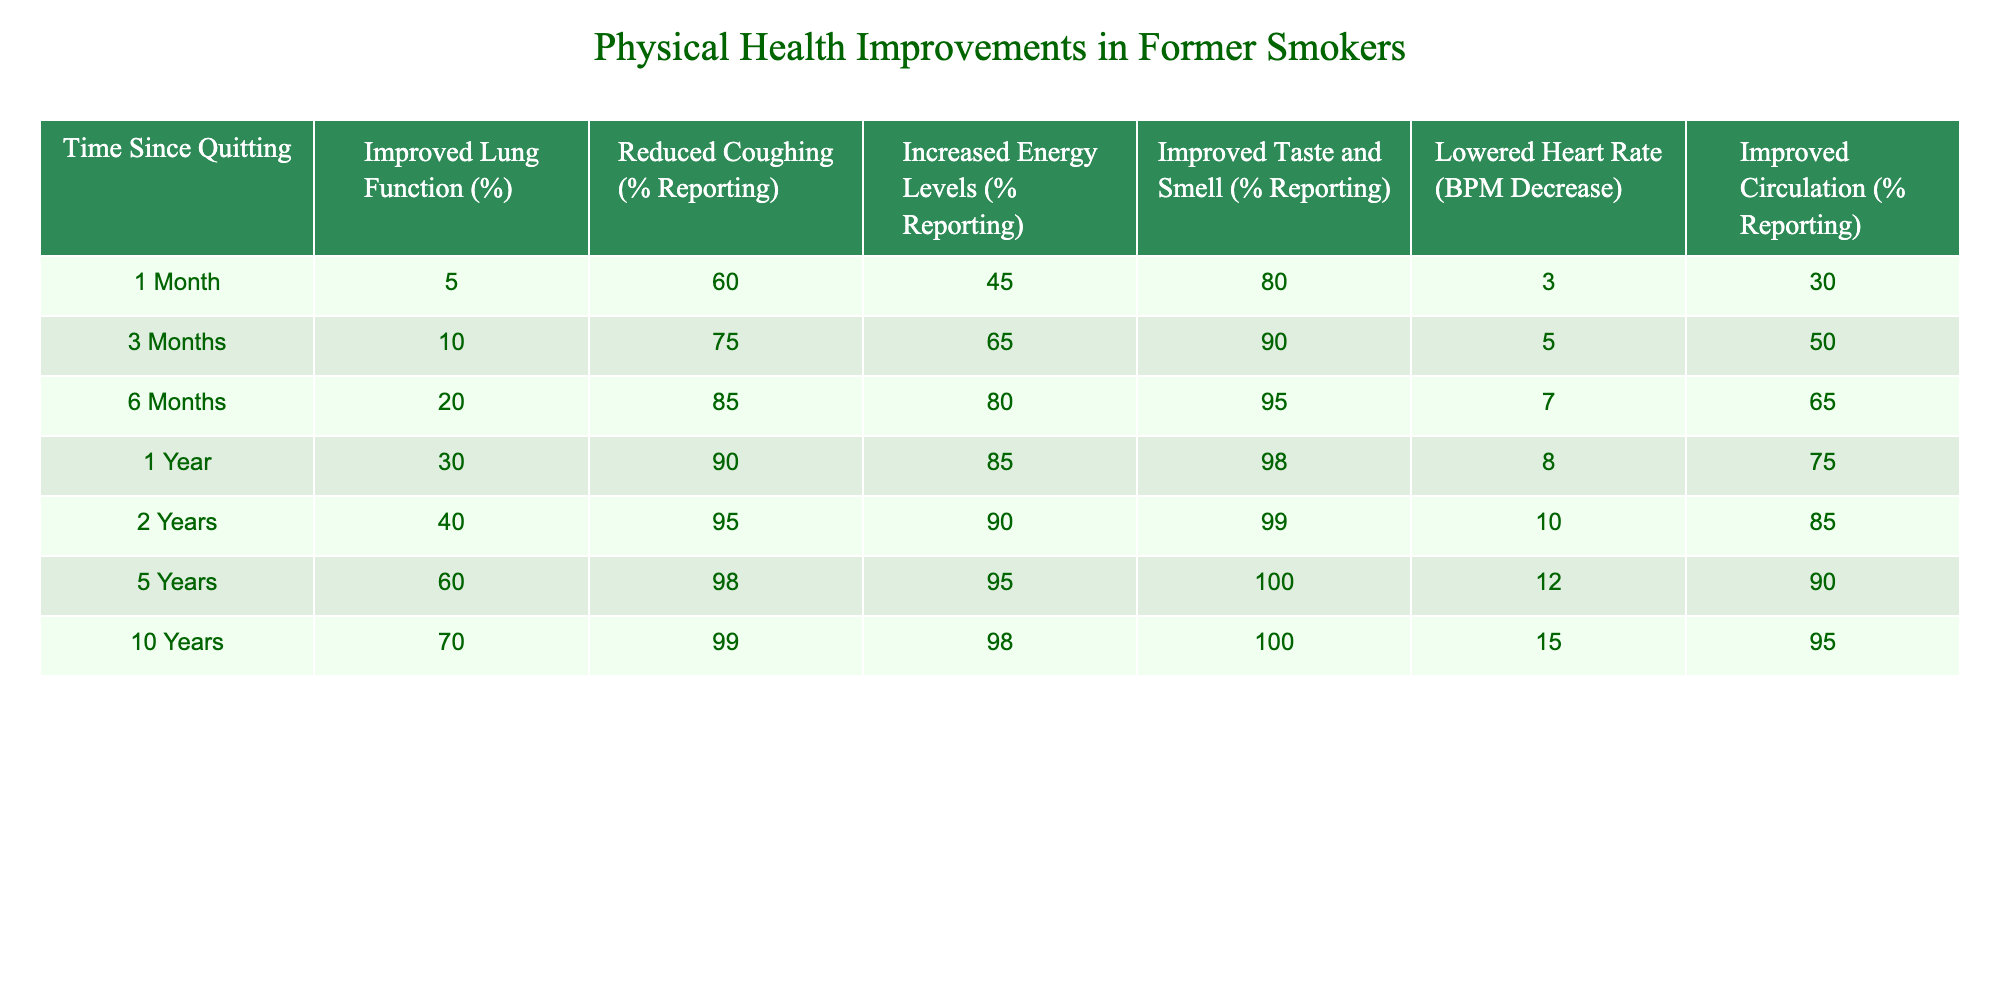What's the percentage of former smokers reporting improved taste and smell after 1 month? From the table, under the "Improved Taste and Smell (% Reporting)" column, the value for "1 Month" is 80%.
Answer: 80% What is the decrease in heart rate (BPM) after 5 years of quitting? The table indicates that the heart rate decrease after 5 years is 12 BPM.
Answer: 12 BPM How many years does it take for former smokers to report 40% improvement in lung function? Referring to the "Improved Lung Function (%)" column, we see that 40% improvement occurs at the 2-year mark.
Answer: 2 years True or False: After 10 years, 98% of former smokers report increased energy levels. In the table, under the "Increased Energy Levels (% Reporting)" column, the value for "10 Years" is 98%. Thus, the statement is true.
Answer: True What is the difference in the percentage of reported reduced coughing between 1 year and 3 months? To find the difference, subtract the "Reduced Coughing (%) Reporting" for 3 months (75%) from that for 1 year (90%), which gives us 90 - 75 = 15%.
Answer: 15% Which time period shows the highest percentage of improved circulation? By examining the "Improved Circulation (% Reporting)" column, the highest percentage of 95% occurs at the 10-year mark.
Answer: 10 years What average percentage of former smokers report increased energy levels at the 1-month, 6-month, and 1-year marks? The percentages are 45%, 80%, and 85% respectively. The average is calculated as (45 + 80 + 85) / 3 = 210 / 3 = 70%.
Answer: 70% At what time point do former smokers begin to report a decrease in heart rate? The data indicates a decrease in heart rate starting from the 1-month mark, with the value at 3 BPM.
Answer: 1 month True or False: The improvement in lung function reaches 70% within the first year of quitting. According to the table, the improvement reaches 30% at 1 year, thus the statement is false.
Answer: False How much does the percentage of improved lung function increase from 1 month to 2 years? The increase from the 1-month value of 5% to the 2-year value of 40% equals 40 - 5 = 35%.
Answer: 35% 